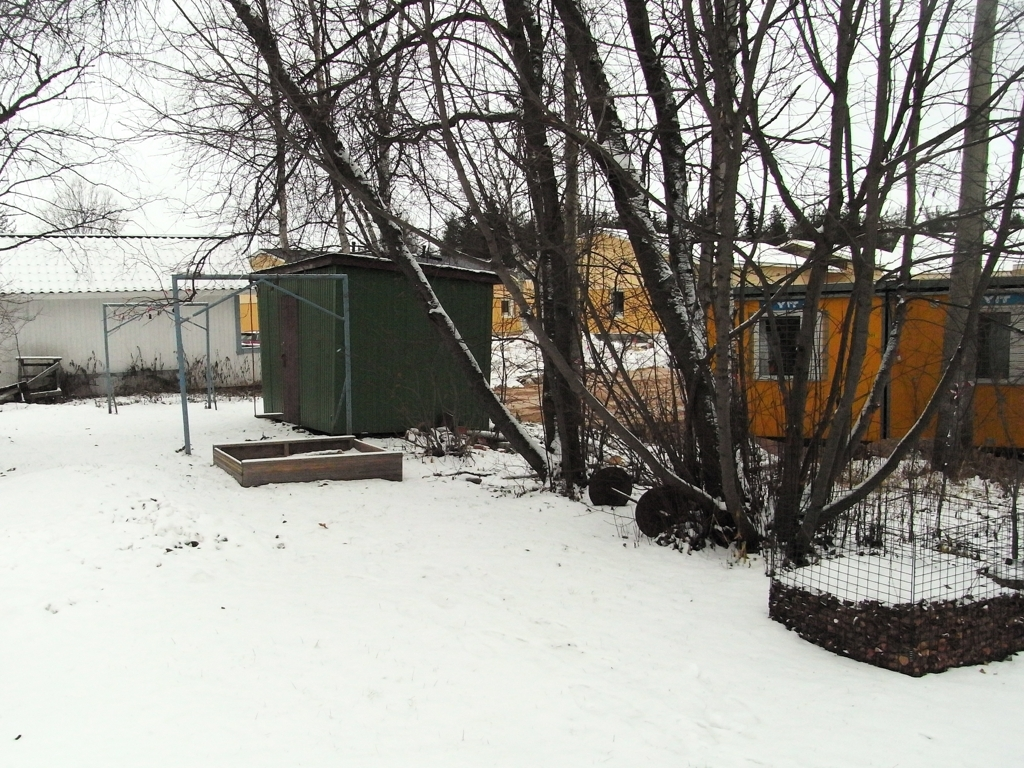Are there any evident focus problems in the image? The image appears to be in focus overall, with clear details visible in the foreground and the background. There are no noticeable blurring or artifacts that would suggest a focus issue. 